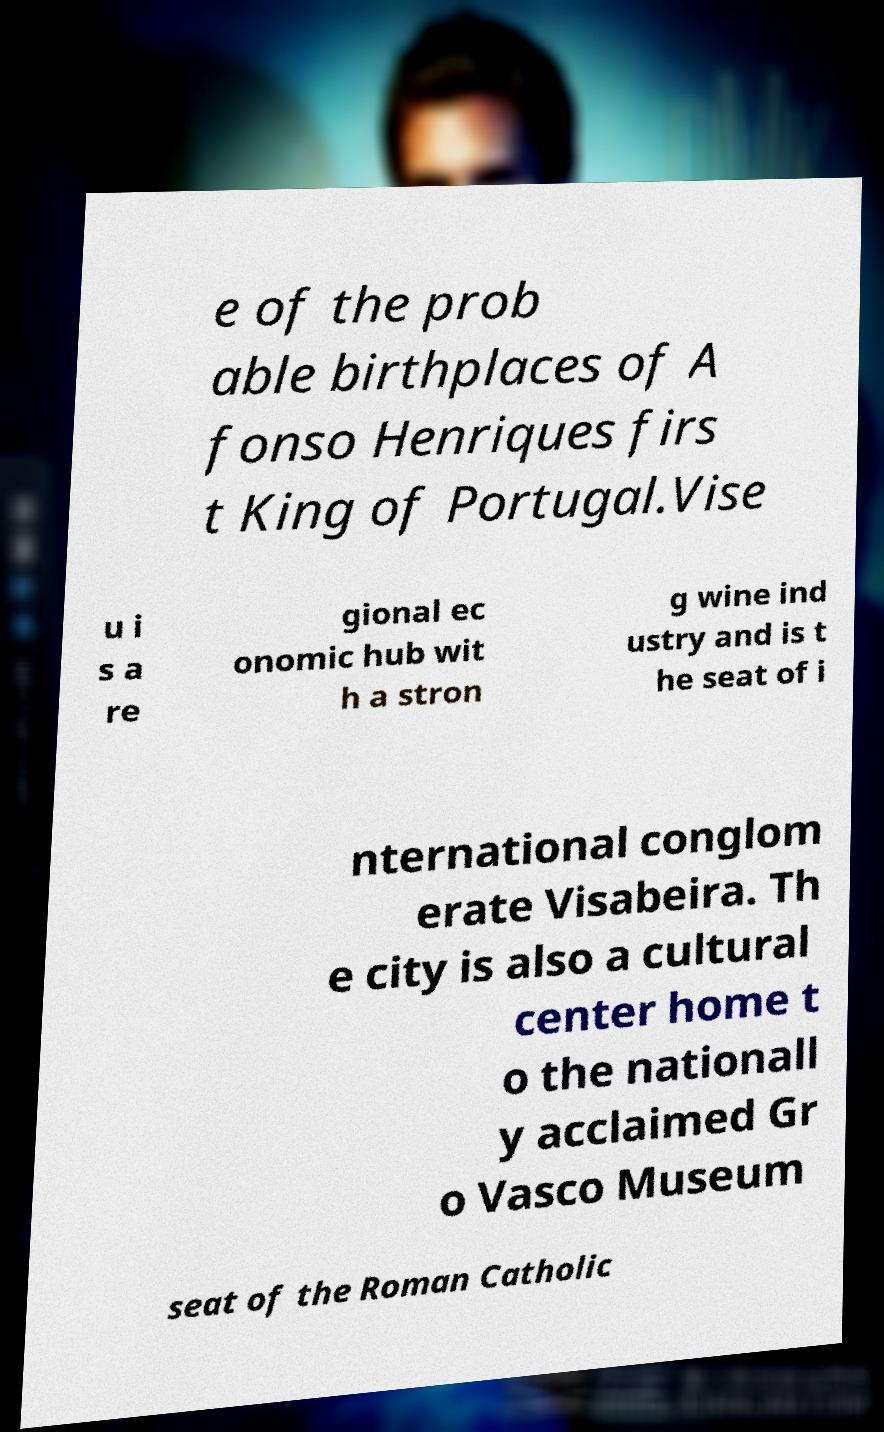Please read and relay the text visible in this image. What does it say? e of the prob able birthplaces of A fonso Henriques firs t King of Portugal.Vise u i s a re gional ec onomic hub wit h a stron g wine ind ustry and is t he seat of i nternational conglom erate Visabeira. Th e city is also a cultural center home t o the nationall y acclaimed Gr o Vasco Museum seat of the Roman Catholic 